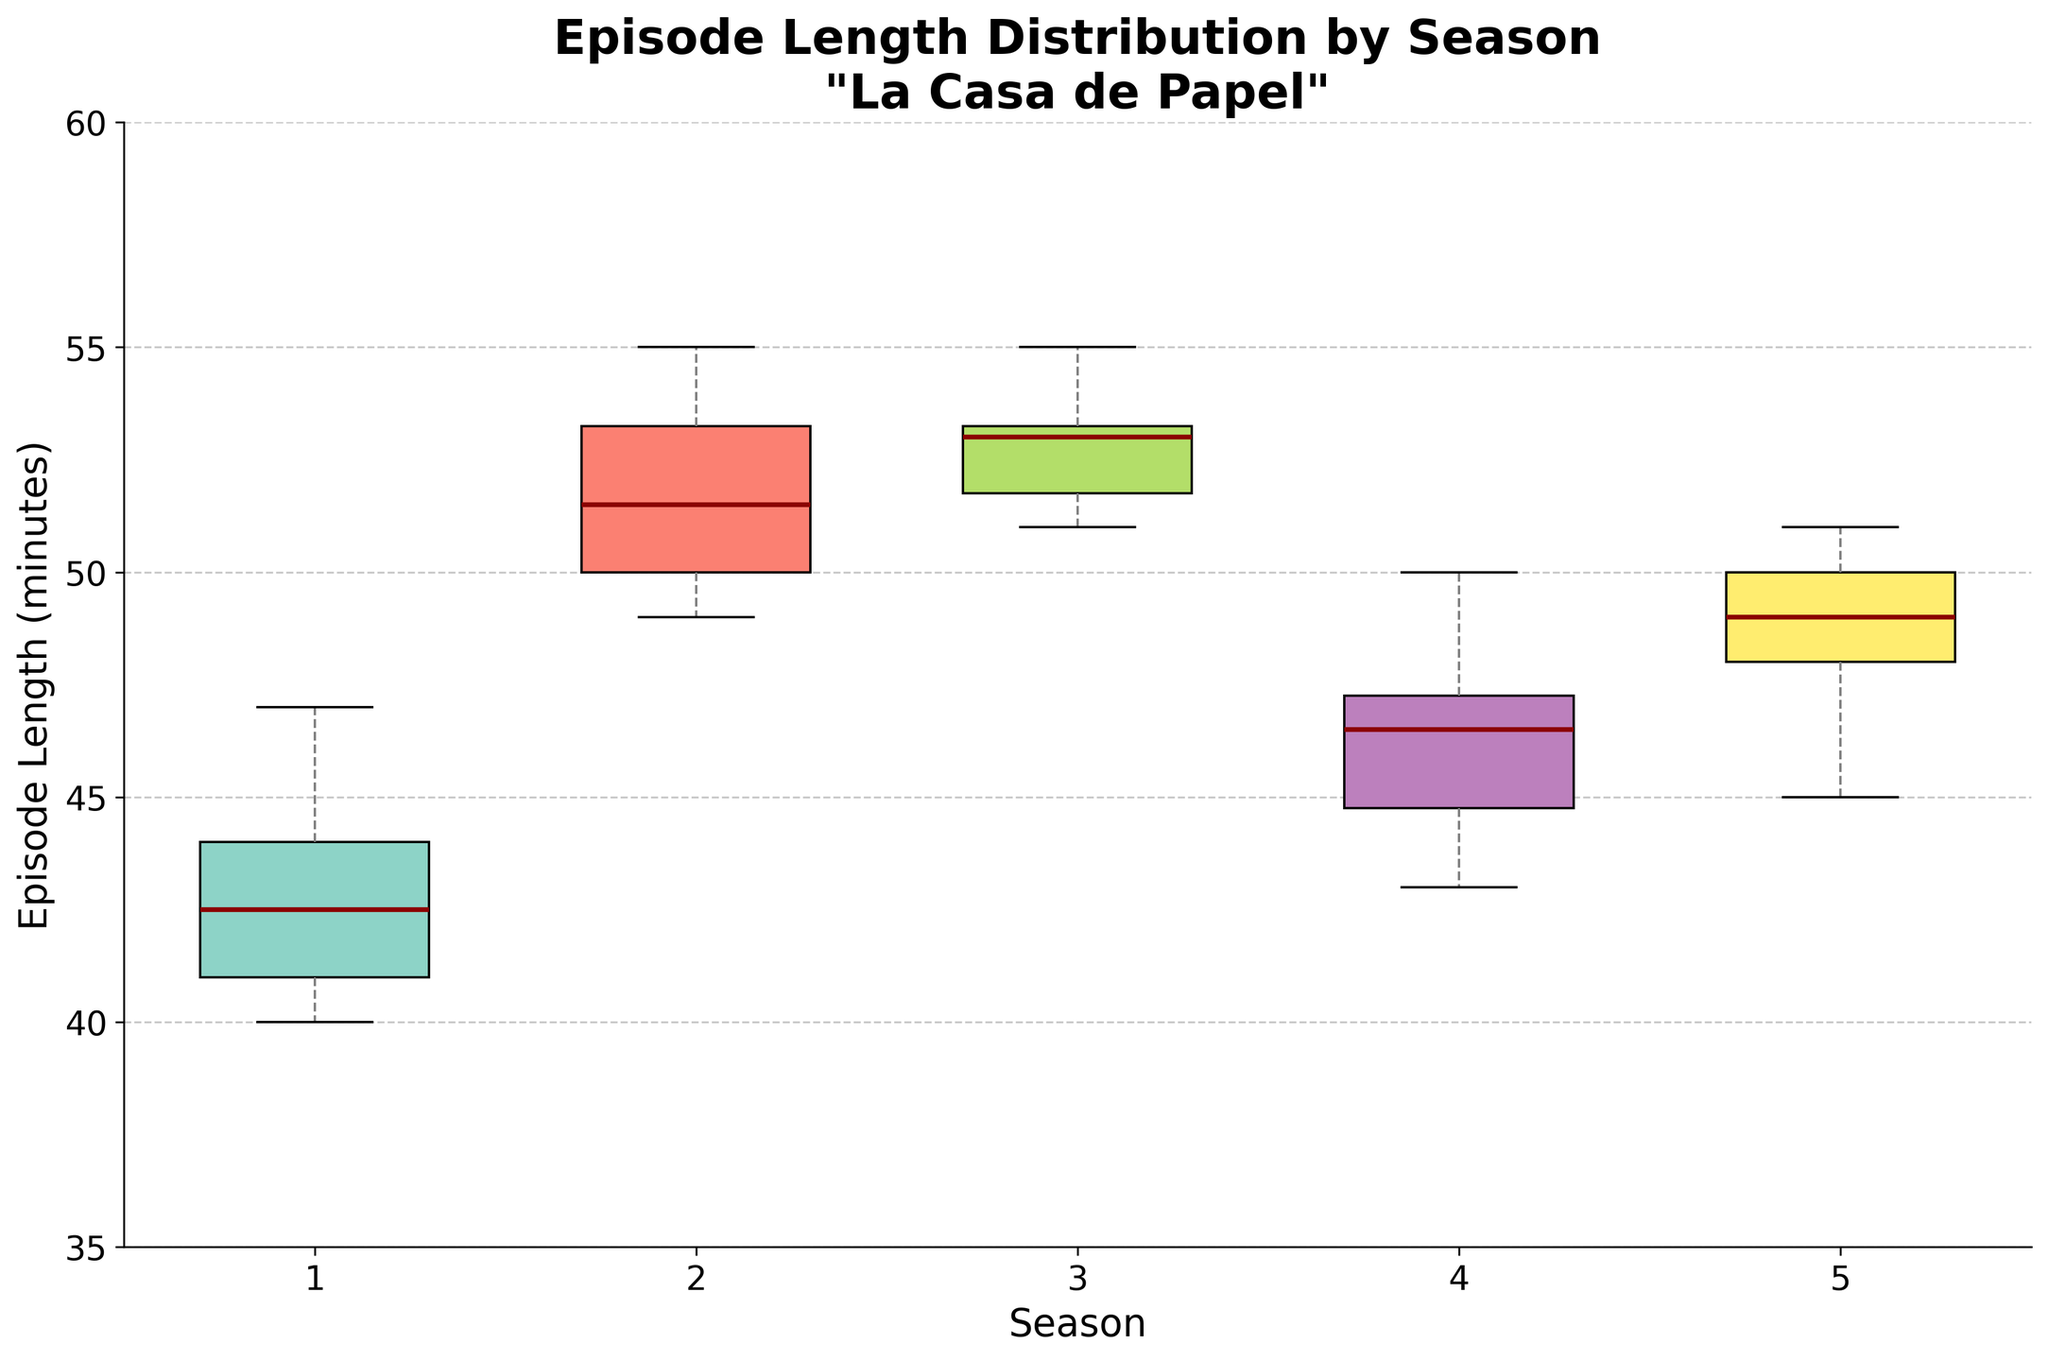What is the title of the figure? The title of the figure is written at the top. It reads 'Episode Length Distribution by Season\n"La Casa de Papel"'
Answer: Episode Length Distribution by Season "La Casa de Papel" What is the median episode length for Season 1? In a box plot, the median is represented by the line inside the box. For Season 1, the median line is around 42 minutes.
Answer: 42 minutes Which season has the widest range of episode lengths? The range of episode lengths in each season can be determined by the distance between the top and bottom whiskers. Season 2 has the widest range, with lengths varying approximately from 49 minutes to 55 minutes.
Answer: Season 2 How many seasons are represented in the figure? The x-axis labels show the number of seasons represented in the figure. There are five seasons in the figure, labeled from 1 to 5.
Answer: 5 seasons What is the shortest episode length across all seasons? The shortest episode length is indicated by the bottom whisker. The shortest episode length across all seasons is about 40 minutes in Season 1.
Answer: 40 minutes Which season has the most consistent episode lengths (smallest spread in lengths)? The consistency of episode lengths can be judged by the size of the interquartile range (IQR), which is the height of the box. Season 4 shows the smallest IQR, indicating the most consistent episode lengths.
Answer: Season 4 Which season has the highest median episode length? Again, by looking at the line inside the box (the median), Season 2 has the highest median episode length of about 51 minutes.
Answer: Season 2 How would you describe the overall trend in episode lengths from Season 1 to Season 5? The overall trend can be observed by looking at the median line across all seasons. There is an upward trend from Season 1 to Season 3, a dip in Season 4, and a rise again in Season 5.
Answer: Upward, then dip in S4, rise in S5 What is the range of episode lengths in Season 3? The range is the difference between the longest and shortest lengths. For Season 3, the range is from about 51 minutes to 55 minutes.
Answer: 4 minutes Are there any seasons with outliers in episode lengths? Outliers are represented by points outside the whiskers. None of the seasons in the box plot show any outlier points.
Answer: No 